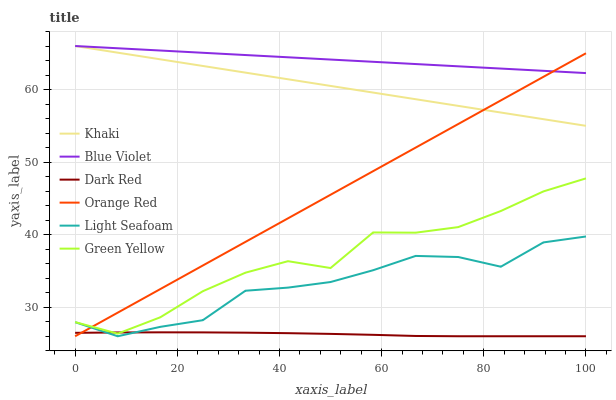Does Dark Red have the minimum area under the curve?
Answer yes or no. Yes. Does Blue Violet have the maximum area under the curve?
Answer yes or no. Yes. Does Khaki have the minimum area under the curve?
Answer yes or no. No. Does Khaki have the maximum area under the curve?
Answer yes or no. No. Is Khaki the smoothest?
Answer yes or no. Yes. Is Green Yellow the roughest?
Answer yes or no. Yes. Is Dark Red the smoothest?
Answer yes or no. No. Is Dark Red the roughest?
Answer yes or no. No. Does Dark Red have the lowest value?
Answer yes or no. Yes. Does Khaki have the lowest value?
Answer yes or no. No. Does Blue Violet have the highest value?
Answer yes or no. Yes. Does Dark Red have the highest value?
Answer yes or no. No. Is Green Yellow less than Blue Violet?
Answer yes or no. Yes. Is Khaki greater than Green Yellow?
Answer yes or no. Yes. Does Orange Red intersect Blue Violet?
Answer yes or no. Yes. Is Orange Red less than Blue Violet?
Answer yes or no. No. Is Orange Red greater than Blue Violet?
Answer yes or no. No. Does Green Yellow intersect Blue Violet?
Answer yes or no. No. 